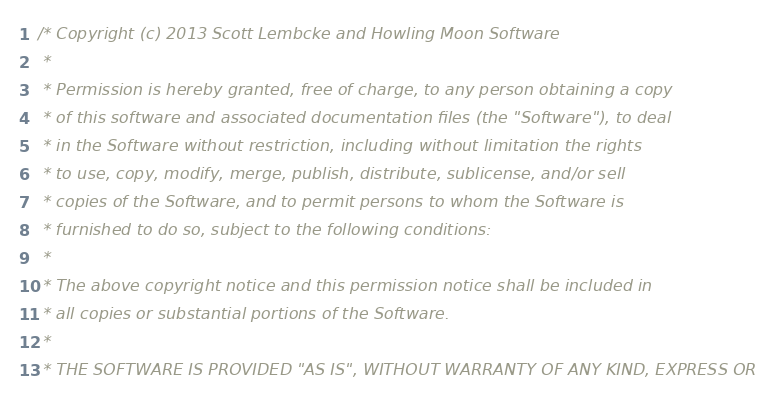Convert code to text. <code><loc_0><loc_0><loc_500><loc_500><_C_>/* Copyright (c) 2013 Scott Lembcke and Howling Moon Software
 * 
 * Permission is hereby granted, free of charge, to any person obtaining a copy
 * of this software and associated documentation files (the "Software"), to deal
 * in the Software without restriction, including without limitation the rights
 * to use, copy, modify, merge, publish, distribute, sublicense, and/or sell
 * copies of the Software, and to permit persons to whom the Software is
 * furnished to do so, subject to the following conditions:
 * 
 * The above copyright notice and this permission notice shall be included in
 * all copies or substantial portions of the Software.
 * 
 * THE SOFTWARE IS PROVIDED "AS IS", WITHOUT WARRANTY OF ANY KIND, EXPRESS OR</code> 